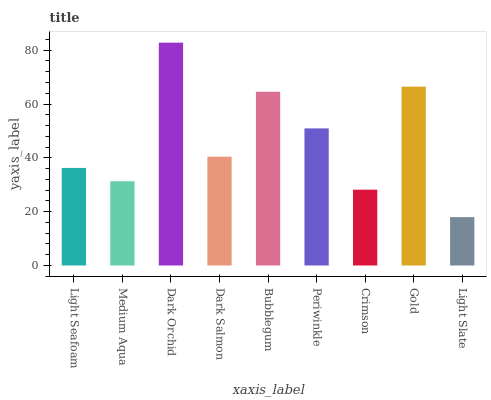Is Medium Aqua the minimum?
Answer yes or no. No. Is Medium Aqua the maximum?
Answer yes or no. No. Is Light Seafoam greater than Medium Aqua?
Answer yes or no. Yes. Is Medium Aqua less than Light Seafoam?
Answer yes or no. Yes. Is Medium Aqua greater than Light Seafoam?
Answer yes or no. No. Is Light Seafoam less than Medium Aqua?
Answer yes or no. No. Is Dark Salmon the high median?
Answer yes or no. Yes. Is Dark Salmon the low median?
Answer yes or no. Yes. Is Dark Orchid the high median?
Answer yes or no. No. Is Light Seafoam the low median?
Answer yes or no. No. 